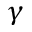Convert formula to latex. <formula><loc_0><loc_0><loc_500><loc_500>\gamma</formula> 